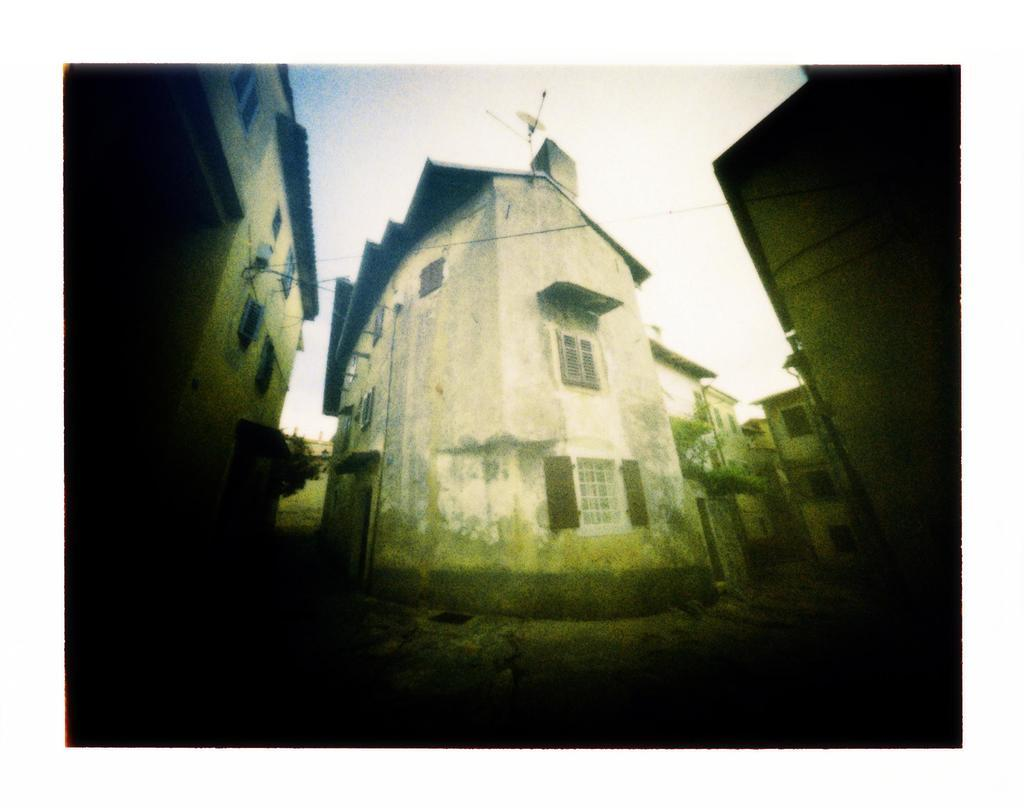What is the main subject of the image? The main subject of the image is a small white color house. Where is the small white house located in the image? The small white house is in the middle of the image. Are there any other houses visible in the image? Yes, there are more houses on both sides of the small white house. How does the potato contribute to the comparison between the houses in the image? There is no potato present in the image, and therefore it cannot contribute to any comparison between the houses. 